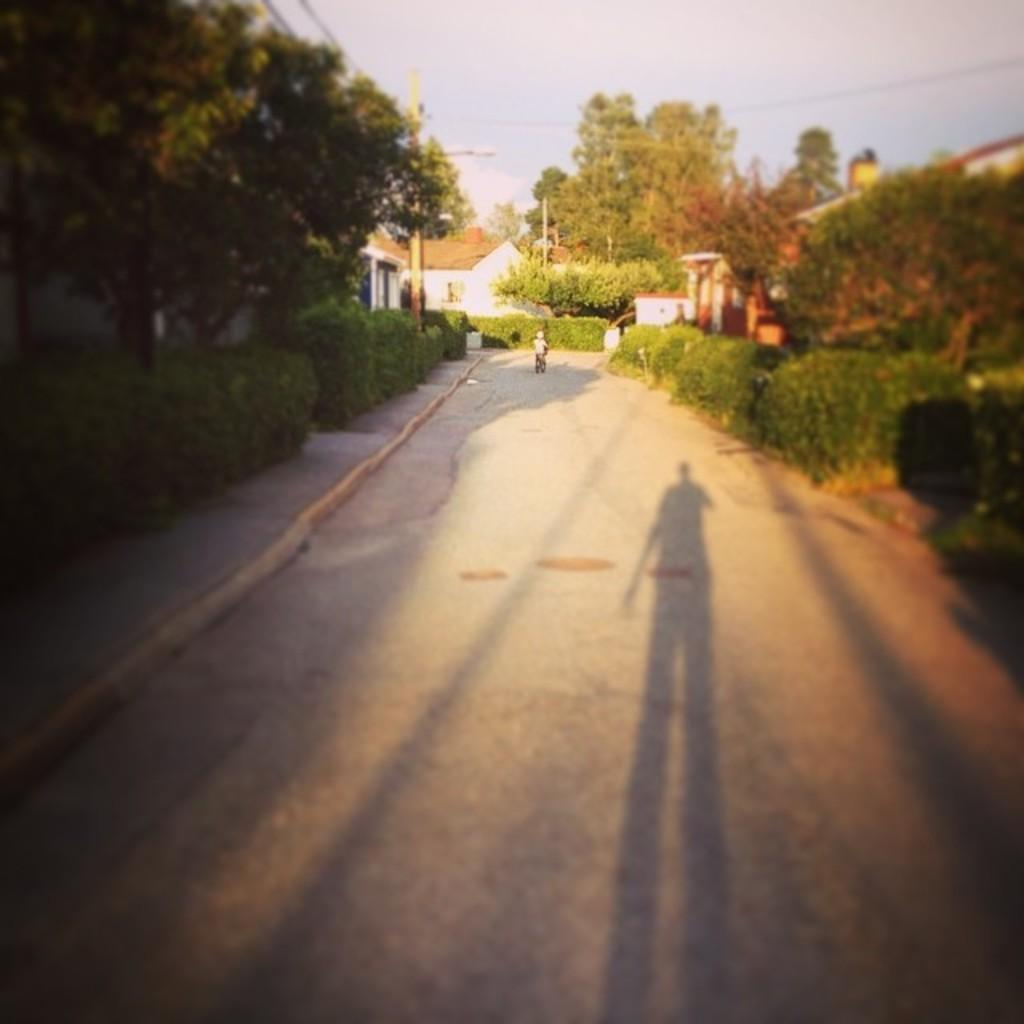What can be seen running through the image? There is a path in the image. What can be observed as a result of the light source in the image? Shadows are visible in the image. What type of vegetation is present in the image? There are plants and trees in the image. What type of man-made structures are visible in the image? There are buildings in the image. What else is present in the image besides the path, shadows, plants, trees, and buildings? Wires are present in the image. What is visible in the background of the image? The sky is visible in the background of the image. What type of advice is being given during the earthquake in the image? There is no earthquake present in the image, and therefore no such advice can be observed. What type of meeting is taking place in the image? There is no meeting present in the image; it features a path, shadows, plants, trees, buildings, wires, and the sky. 